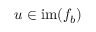Convert formula to latex. <formula><loc_0><loc_0><loc_500><loc_500>u \in i m ( f _ { b } )</formula> 